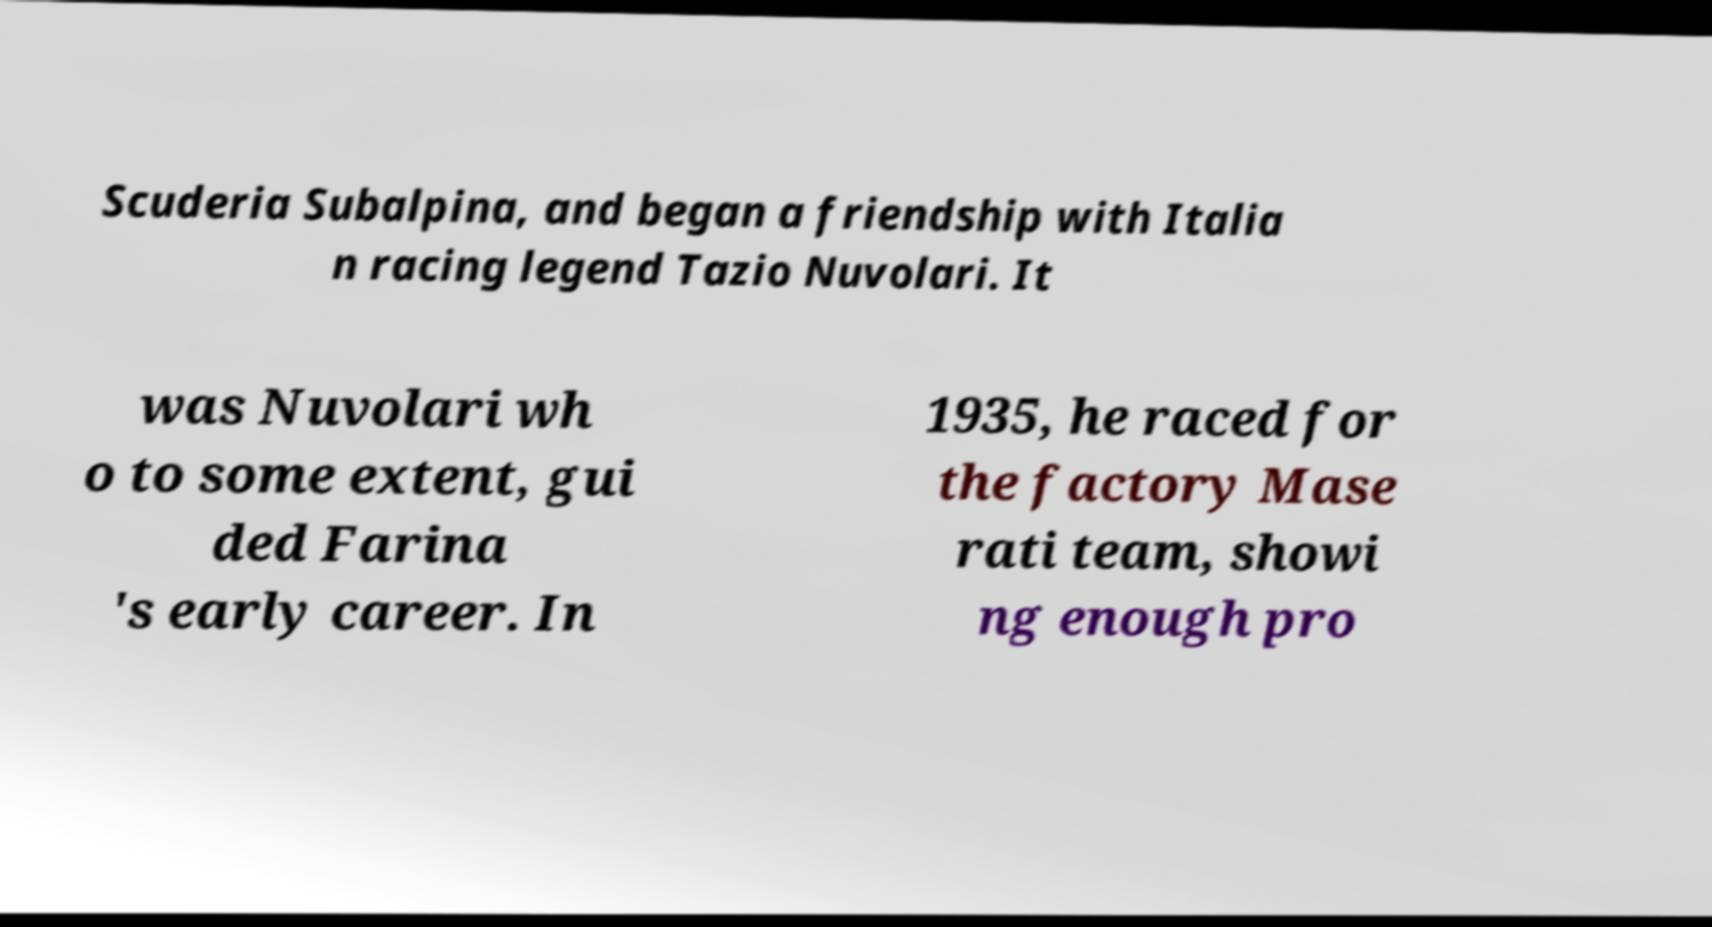I need the written content from this picture converted into text. Can you do that? Scuderia Subalpina, and began a friendship with Italia n racing legend Tazio Nuvolari. It was Nuvolari wh o to some extent, gui ded Farina 's early career. In 1935, he raced for the factory Mase rati team, showi ng enough pro 